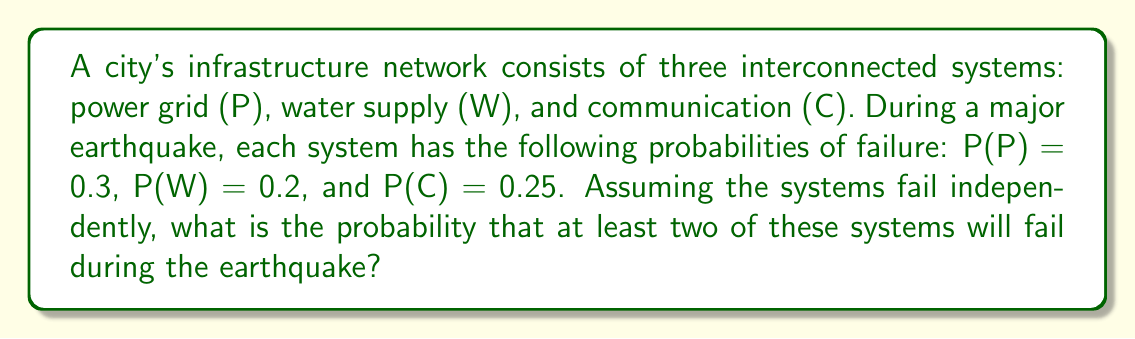Could you help me with this problem? To solve this problem, we'll use the complement method and the multiplication rule for independent events.

Step 1: Calculate the probability that all systems survive.
P(all survive) = P(P' ∩ W' ∩ C')
$$ P(\text{all survive}) = (1 - 0.3) \times (1 - 0.2) \times (1 - 0.25) = 0.7 \times 0.8 \times 0.75 = 0.42 $$

Step 2: Calculate the probability that exactly one system fails.

For power grid failure only:
$$ P(P \cap W' \cap C') = 0.3 \times 0.8 \times 0.75 = 0.18 $$

For water supply failure only:
$$ P(P' \cap W \cap C') = 0.7 \times 0.2 \times 0.75 = 0.105 $$

For communication failure only:
$$ P(P' \cap W' \cap C) = 0.7 \times 0.8 \times 0.25 = 0.14 $$

Sum of probabilities for exactly one failure:
$$ P(\text{exactly one fails}) = 0.18 + 0.105 + 0.14 = 0.425 $$

Step 3: Calculate the probability of at least two systems failing using the complement method.
$$ P(\text{at least two fail}) = 1 - P(\text{all survive}) - P(\text{exactly one fails}) $$
$$ P(\text{at least two fail}) = 1 - 0.42 - 0.425 = 0.155 $$

Therefore, the probability that at least two systems will fail during the earthquake is 0.155 or 15.5%.
Answer: 0.155 